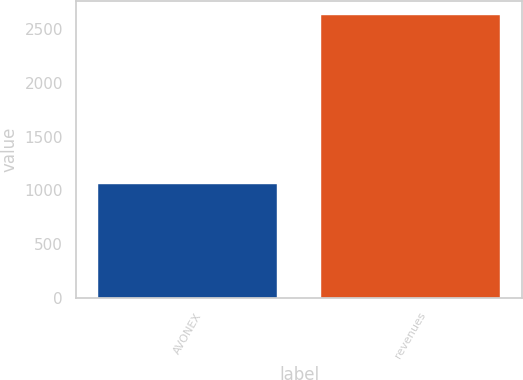Convert chart to OTSL. <chart><loc_0><loc_0><loc_500><loc_500><bar_chart><fcel>AVONEX<fcel>revenues<nl><fcel>1056.4<fcel>2636.7<nl></chart> 